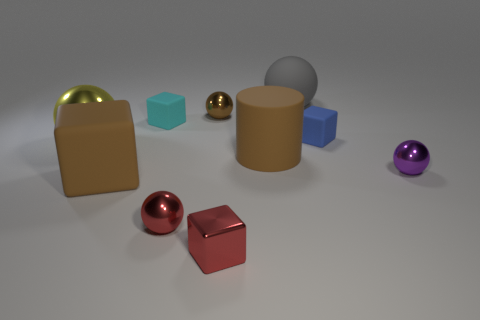There is a blue rubber object that is the same size as the brown ball; what is its shape?
Ensure brevity in your answer.  Cube. What is the color of the big sphere that is the same material as the red block?
Offer a terse response. Yellow. Do the tiny blue matte object and the small shiny thing on the right side of the tiny red metallic block have the same shape?
Offer a terse response. No. What material is the small object that is the same color as the big rubber block?
Provide a succinct answer. Metal. What is the material of the red sphere that is the same size as the metallic block?
Keep it short and to the point. Metal. Are there any blocks that have the same color as the cylinder?
Offer a very short reply. Yes. What is the shape of the object that is both right of the brown metallic thing and behind the cyan object?
Keep it short and to the point. Sphere. How many large brown things have the same material as the large gray object?
Make the answer very short. 2. Is the number of tiny cyan cubes that are in front of the cylinder less than the number of blocks on the right side of the tiny cyan object?
Keep it short and to the point. Yes. What is the material of the big brown object on the right side of the brown matte thing on the left side of the small block in front of the small blue object?
Offer a terse response. Rubber. 